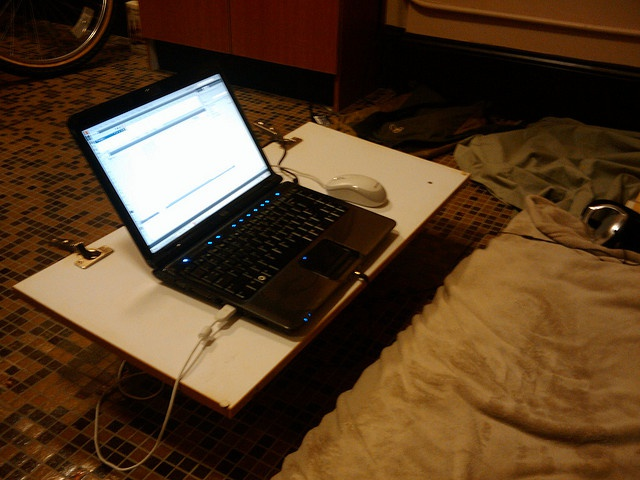Describe the objects in this image and their specific colors. I can see bed in black, olive, and maroon tones, couch in black, olive, and maroon tones, laptop in black, white, lightblue, and maroon tones, bicycle in black, maroon, and brown tones, and mouse in black, olive, and tan tones in this image. 